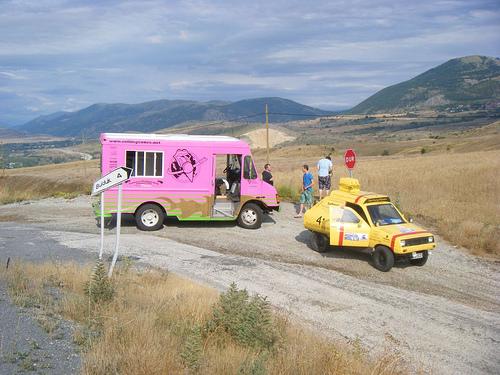Is the van moving?
Short answer required. No. Is the place deserted?
Quick response, please. No. What is the pink thing?
Quick response, please. Truck. What is on top of the car?
Write a very short answer. Luggage. 